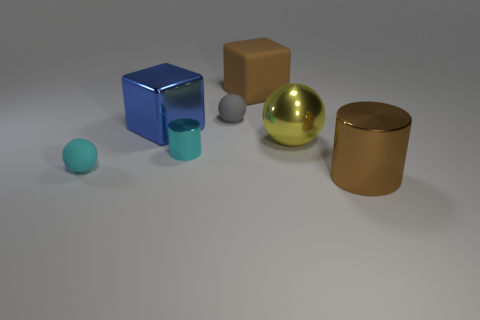Subtract all matte balls. How many balls are left? 1 Add 3 cyan things. How many objects exist? 10 Subtract all blocks. How many objects are left? 5 Add 7 brown blocks. How many brown blocks are left? 8 Add 3 small spheres. How many small spheres exist? 5 Subtract 1 gray spheres. How many objects are left? 6 Subtract all large metal balls. Subtract all cylinders. How many objects are left? 4 